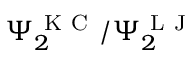Convert formula to latex. <formula><loc_0><loc_0><loc_500><loc_500>\Psi _ { 2 } ^ { K C } / \Psi _ { 2 } ^ { L J }</formula> 